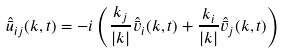Convert formula to latex. <formula><loc_0><loc_0><loc_500><loc_500>\hat { \bar { u } } _ { i j } ( k , t ) = - i \left ( \frac { k _ { j } } { | k | } \hat { \bar { v } } _ { i } ( k , t ) + \frac { k _ { i } } { | k | } \hat { \bar { v } } _ { j } ( k , t ) \right )</formula> 